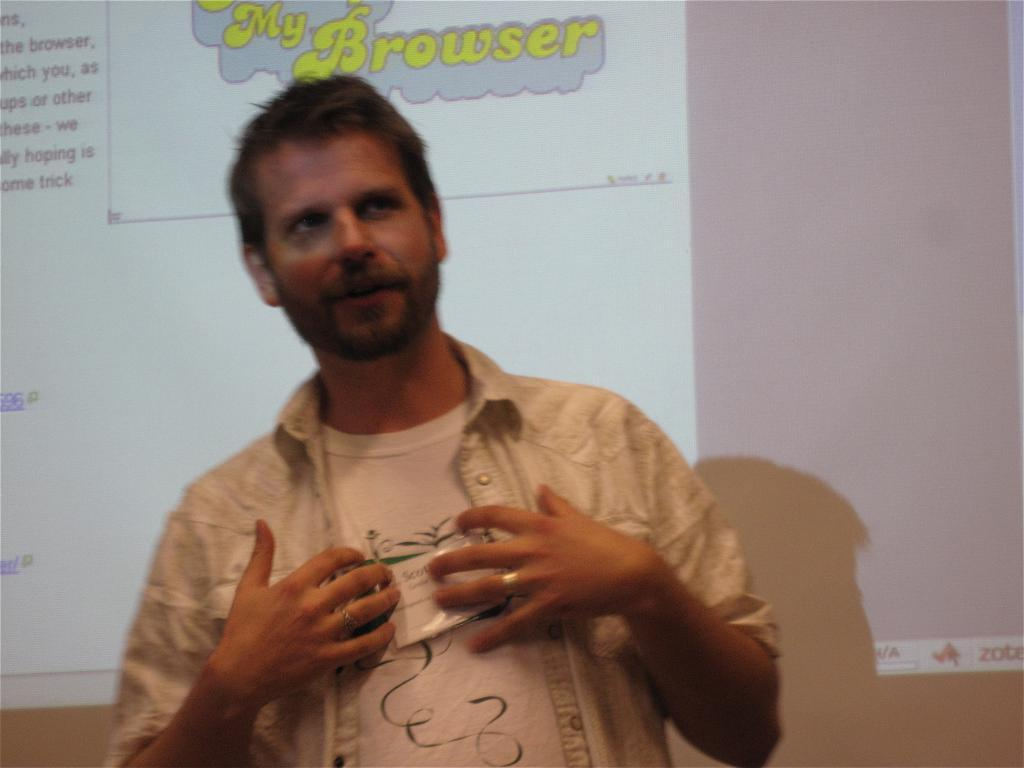Who or what is present in the image? There is a person in the image. What is the person wearing? The person is wearing a white shirt. What is the person's posture in the image? The person is standing. What can be seen in the background of the image? There is a screen in the background of the image. What is displayed on the screen? The screen has text on it. Is the person's mom visible in the image? There is no mention of the person's mom in the provided facts, so we cannot determine if she is visible in the image. Are there any squirrels present in the image? There is no mention of squirrels in the provided facts, so we cannot determine if any are present in the image. 